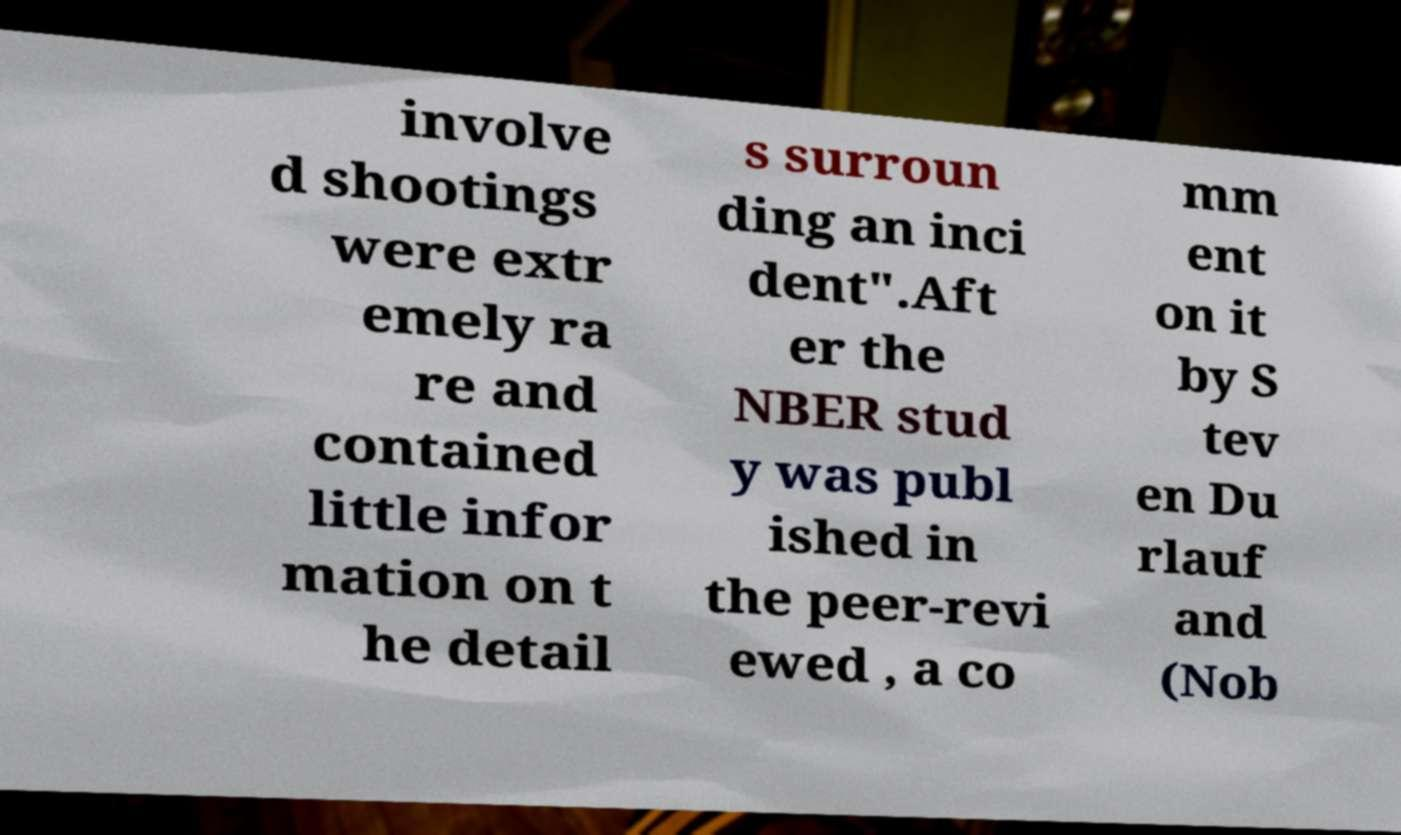Could you assist in decoding the text presented in this image and type it out clearly? involve d shootings were extr emely ra re and contained little infor mation on t he detail s surroun ding an inci dent".Aft er the NBER stud y was publ ished in the peer-revi ewed , a co mm ent on it by S tev en Du rlauf and (Nob 